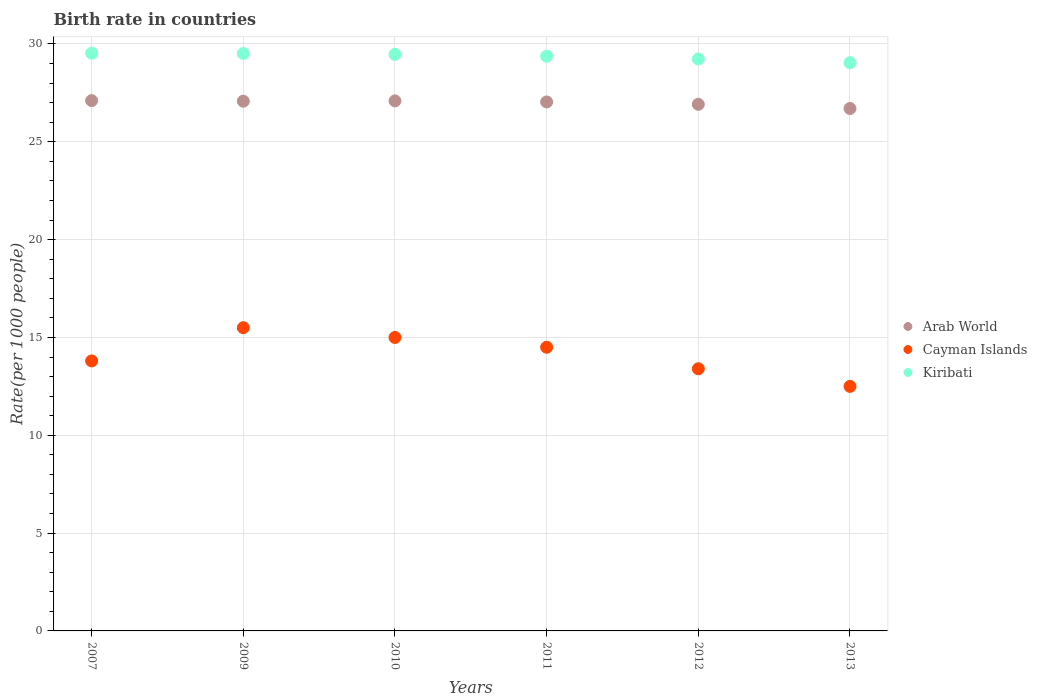How many different coloured dotlines are there?
Make the answer very short. 3. Is the number of dotlines equal to the number of legend labels?
Your answer should be compact. Yes. What is the birth rate in Cayman Islands in 2010?
Make the answer very short. 15. Across all years, what is the minimum birth rate in Kiribati?
Provide a short and direct response. 29.04. In which year was the birth rate in Cayman Islands maximum?
Give a very brief answer. 2009. In which year was the birth rate in Cayman Islands minimum?
Keep it short and to the point. 2013. What is the total birth rate in Cayman Islands in the graph?
Make the answer very short. 84.7. What is the difference between the birth rate in Cayman Islands in 2012 and that in 2013?
Keep it short and to the point. 0.9. What is the difference between the birth rate in Arab World in 2011 and the birth rate in Cayman Islands in 2010?
Your answer should be very brief. 12.04. What is the average birth rate in Arab World per year?
Your answer should be compact. 26.99. In the year 2011, what is the difference between the birth rate in Arab World and birth rate in Cayman Islands?
Offer a very short reply. 12.54. What is the ratio of the birth rate in Arab World in 2007 to that in 2013?
Keep it short and to the point. 1.02. Is the birth rate in Arab World in 2009 less than that in 2012?
Offer a terse response. No. Is the difference between the birth rate in Arab World in 2007 and 2012 greater than the difference between the birth rate in Cayman Islands in 2007 and 2012?
Provide a succinct answer. No. Is the sum of the birth rate in Kiribati in 2007 and 2011 greater than the maximum birth rate in Cayman Islands across all years?
Ensure brevity in your answer.  Yes. Is it the case that in every year, the sum of the birth rate in Kiribati and birth rate in Cayman Islands  is greater than the birth rate in Arab World?
Provide a succinct answer. Yes. Does the birth rate in Cayman Islands monotonically increase over the years?
Offer a very short reply. No. Is the birth rate in Cayman Islands strictly less than the birth rate in Arab World over the years?
Give a very brief answer. Yes. How many years are there in the graph?
Ensure brevity in your answer.  6. Are the values on the major ticks of Y-axis written in scientific E-notation?
Make the answer very short. No. Does the graph contain any zero values?
Offer a very short reply. No. What is the title of the graph?
Give a very brief answer. Birth rate in countries. Does "Pacific island small states" appear as one of the legend labels in the graph?
Provide a succinct answer. No. What is the label or title of the X-axis?
Offer a very short reply. Years. What is the label or title of the Y-axis?
Your answer should be compact. Rate(per 1000 people). What is the Rate(per 1000 people) of Arab World in 2007?
Ensure brevity in your answer.  27.11. What is the Rate(per 1000 people) of Cayman Islands in 2007?
Offer a very short reply. 13.8. What is the Rate(per 1000 people) in Kiribati in 2007?
Your response must be concise. 29.53. What is the Rate(per 1000 people) in Arab World in 2009?
Provide a succinct answer. 27.08. What is the Rate(per 1000 people) in Cayman Islands in 2009?
Ensure brevity in your answer.  15.5. What is the Rate(per 1000 people) in Kiribati in 2009?
Offer a very short reply. 29.51. What is the Rate(per 1000 people) in Arab World in 2010?
Make the answer very short. 27.09. What is the Rate(per 1000 people) in Kiribati in 2010?
Keep it short and to the point. 29.47. What is the Rate(per 1000 people) of Arab World in 2011?
Provide a short and direct response. 27.04. What is the Rate(per 1000 people) of Cayman Islands in 2011?
Provide a short and direct response. 14.5. What is the Rate(per 1000 people) of Kiribati in 2011?
Make the answer very short. 29.38. What is the Rate(per 1000 people) in Arab World in 2012?
Make the answer very short. 26.92. What is the Rate(per 1000 people) of Kiribati in 2012?
Give a very brief answer. 29.23. What is the Rate(per 1000 people) in Arab World in 2013?
Keep it short and to the point. 26.7. What is the Rate(per 1000 people) in Cayman Islands in 2013?
Your response must be concise. 12.5. What is the Rate(per 1000 people) of Kiribati in 2013?
Your answer should be very brief. 29.04. Across all years, what is the maximum Rate(per 1000 people) of Arab World?
Your answer should be compact. 27.11. Across all years, what is the maximum Rate(per 1000 people) of Cayman Islands?
Give a very brief answer. 15.5. Across all years, what is the maximum Rate(per 1000 people) of Kiribati?
Your response must be concise. 29.53. Across all years, what is the minimum Rate(per 1000 people) in Arab World?
Your answer should be compact. 26.7. Across all years, what is the minimum Rate(per 1000 people) of Kiribati?
Ensure brevity in your answer.  29.04. What is the total Rate(per 1000 people) in Arab World in the graph?
Your answer should be compact. 161.93. What is the total Rate(per 1000 people) of Cayman Islands in the graph?
Provide a short and direct response. 84.7. What is the total Rate(per 1000 people) of Kiribati in the graph?
Your answer should be compact. 176.16. What is the difference between the Rate(per 1000 people) of Arab World in 2007 and that in 2009?
Provide a short and direct response. 0.03. What is the difference between the Rate(per 1000 people) in Cayman Islands in 2007 and that in 2009?
Ensure brevity in your answer.  -1.7. What is the difference between the Rate(per 1000 people) of Kiribati in 2007 and that in 2009?
Ensure brevity in your answer.  0.01. What is the difference between the Rate(per 1000 people) of Arab World in 2007 and that in 2010?
Ensure brevity in your answer.  0.01. What is the difference between the Rate(per 1000 people) in Cayman Islands in 2007 and that in 2010?
Give a very brief answer. -1.2. What is the difference between the Rate(per 1000 people) of Arab World in 2007 and that in 2011?
Keep it short and to the point. 0.07. What is the difference between the Rate(per 1000 people) in Cayman Islands in 2007 and that in 2011?
Offer a very short reply. -0.7. What is the difference between the Rate(per 1000 people) in Kiribati in 2007 and that in 2011?
Offer a terse response. 0.15. What is the difference between the Rate(per 1000 people) of Arab World in 2007 and that in 2012?
Keep it short and to the point. 0.19. What is the difference between the Rate(per 1000 people) of Kiribati in 2007 and that in 2012?
Offer a terse response. 0.29. What is the difference between the Rate(per 1000 people) in Arab World in 2007 and that in 2013?
Provide a short and direct response. 0.4. What is the difference between the Rate(per 1000 people) of Kiribati in 2007 and that in 2013?
Provide a succinct answer. 0.48. What is the difference between the Rate(per 1000 people) of Arab World in 2009 and that in 2010?
Keep it short and to the point. -0.02. What is the difference between the Rate(per 1000 people) in Cayman Islands in 2009 and that in 2010?
Give a very brief answer. 0.5. What is the difference between the Rate(per 1000 people) of Kiribati in 2009 and that in 2010?
Keep it short and to the point. 0.04. What is the difference between the Rate(per 1000 people) in Arab World in 2009 and that in 2011?
Your answer should be compact. 0.04. What is the difference between the Rate(per 1000 people) in Kiribati in 2009 and that in 2011?
Your answer should be compact. 0.14. What is the difference between the Rate(per 1000 people) of Arab World in 2009 and that in 2012?
Make the answer very short. 0.16. What is the difference between the Rate(per 1000 people) in Kiribati in 2009 and that in 2012?
Your answer should be compact. 0.28. What is the difference between the Rate(per 1000 people) of Arab World in 2009 and that in 2013?
Ensure brevity in your answer.  0.37. What is the difference between the Rate(per 1000 people) in Kiribati in 2009 and that in 2013?
Your response must be concise. 0.47. What is the difference between the Rate(per 1000 people) in Arab World in 2010 and that in 2011?
Make the answer very short. 0.05. What is the difference between the Rate(per 1000 people) in Kiribati in 2010 and that in 2011?
Provide a succinct answer. 0.09. What is the difference between the Rate(per 1000 people) of Arab World in 2010 and that in 2012?
Ensure brevity in your answer.  0.17. What is the difference between the Rate(per 1000 people) of Cayman Islands in 2010 and that in 2012?
Provide a succinct answer. 1.6. What is the difference between the Rate(per 1000 people) of Kiribati in 2010 and that in 2012?
Give a very brief answer. 0.23. What is the difference between the Rate(per 1000 people) in Arab World in 2010 and that in 2013?
Your answer should be compact. 0.39. What is the difference between the Rate(per 1000 people) in Cayman Islands in 2010 and that in 2013?
Your answer should be compact. 2.5. What is the difference between the Rate(per 1000 people) in Kiribati in 2010 and that in 2013?
Keep it short and to the point. 0.42. What is the difference between the Rate(per 1000 people) of Arab World in 2011 and that in 2012?
Give a very brief answer. 0.12. What is the difference between the Rate(per 1000 people) in Cayman Islands in 2011 and that in 2012?
Give a very brief answer. 1.1. What is the difference between the Rate(per 1000 people) in Kiribati in 2011 and that in 2012?
Ensure brevity in your answer.  0.14. What is the difference between the Rate(per 1000 people) in Arab World in 2011 and that in 2013?
Your answer should be very brief. 0.33. What is the difference between the Rate(per 1000 people) of Kiribati in 2011 and that in 2013?
Give a very brief answer. 0.33. What is the difference between the Rate(per 1000 people) in Arab World in 2012 and that in 2013?
Your response must be concise. 0.21. What is the difference between the Rate(per 1000 people) of Kiribati in 2012 and that in 2013?
Provide a succinct answer. 0.19. What is the difference between the Rate(per 1000 people) in Arab World in 2007 and the Rate(per 1000 people) in Cayman Islands in 2009?
Offer a terse response. 11.61. What is the difference between the Rate(per 1000 people) of Arab World in 2007 and the Rate(per 1000 people) of Kiribati in 2009?
Your answer should be compact. -2.41. What is the difference between the Rate(per 1000 people) in Cayman Islands in 2007 and the Rate(per 1000 people) in Kiribati in 2009?
Your answer should be compact. -15.71. What is the difference between the Rate(per 1000 people) in Arab World in 2007 and the Rate(per 1000 people) in Cayman Islands in 2010?
Offer a very short reply. 12.11. What is the difference between the Rate(per 1000 people) in Arab World in 2007 and the Rate(per 1000 people) in Kiribati in 2010?
Provide a succinct answer. -2.36. What is the difference between the Rate(per 1000 people) of Cayman Islands in 2007 and the Rate(per 1000 people) of Kiribati in 2010?
Keep it short and to the point. -15.67. What is the difference between the Rate(per 1000 people) of Arab World in 2007 and the Rate(per 1000 people) of Cayman Islands in 2011?
Keep it short and to the point. 12.61. What is the difference between the Rate(per 1000 people) of Arab World in 2007 and the Rate(per 1000 people) of Kiribati in 2011?
Make the answer very short. -2.27. What is the difference between the Rate(per 1000 people) in Cayman Islands in 2007 and the Rate(per 1000 people) in Kiribati in 2011?
Give a very brief answer. -15.58. What is the difference between the Rate(per 1000 people) in Arab World in 2007 and the Rate(per 1000 people) in Cayman Islands in 2012?
Your answer should be very brief. 13.71. What is the difference between the Rate(per 1000 people) of Arab World in 2007 and the Rate(per 1000 people) of Kiribati in 2012?
Provide a short and direct response. -2.13. What is the difference between the Rate(per 1000 people) of Cayman Islands in 2007 and the Rate(per 1000 people) of Kiribati in 2012?
Give a very brief answer. -15.44. What is the difference between the Rate(per 1000 people) in Arab World in 2007 and the Rate(per 1000 people) in Cayman Islands in 2013?
Your answer should be compact. 14.61. What is the difference between the Rate(per 1000 people) of Arab World in 2007 and the Rate(per 1000 people) of Kiribati in 2013?
Offer a terse response. -1.94. What is the difference between the Rate(per 1000 people) of Cayman Islands in 2007 and the Rate(per 1000 people) of Kiribati in 2013?
Provide a short and direct response. -15.24. What is the difference between the Rate(per 1000 people) in Arab World in 2009 and the Rate(per 1000 people) in Cayman Islands in 2010?
Give a very brief answer. 12.08. What is the difference between the Rate(per 1000 people) of Arab World in 2009 and the Rate(per 1000 people) of Kiribati in 2010?
Make the answer very short. -2.39. What is the difference between the Rate(per 1000 people) of Cayman Islands in 2009 and the Rate(per 1000 people) of Kiribati in 2010?
Keep it short and to the point. -13.97. What is the difference between the Rate(per 1000 people) of Arab World in 2009 and the Rate(per 1000 people) of Cayman Islands in 2011?
Offer a very short reply. 12.58. What is the difference between the Rate(per 1000 people) of Arab World in 2009 and the Rate(per 1000 people) of Kiribati in 2011?
Your answer should be compact. -2.3. What is the difference between the Rate(per 1000 people) of Cayman Islands in 2009 and the Rate(per 1000 people) of Kiribati in 2011?
Your response must be concise. -13.88. What is the difference between the Rate(per 1000 people) in Arab World in 2009 and the Rate(per 1000 people) in Cayman Islands in 2012?
Offer a very short reply. 13.68. What is the difference between the Rate(per 1000 people) of Arab World in 2009 and the Rate(per 1000 people) of Kiribati in 2012?
Provide a succinct answer. -2.16. What is the difference between the Rate(per 1000 people) of Cayman Islands in 2009 and the Rate(per 1000 people) of Kiribati in 2012?
Make the answer very short. -13.73. What is the difference between the Rate(per 1000 people) of Arab World in 2009 and the Rate(per 1000 people) of Cayman Islands in 2013?
Your answer should be compact. 14.58. What is the difference between the Rate(per 1000 people) of Arab World in 2009 and the Rate(per 1000 people) of Kiribati in 2013?
Provide a succinct answer. -1.97. What is the difference between the Rate(per 1000 people) of Cayman Islands in 2009 and the Rate(per 1000 people) of Kiribati in 2013?
Provide a succinct answer. -13.54. What is the difference between the Rate(per 1000 people) in Arab World in 2010 and the Rate(per 1000 people) in Cayman Islands in 2011?
Your answer should be compact. 12.59. What is the difference between the Rate(per 1000 people) of Arab World in 2010 and the Rate(per 1000 people) of Kiribati in 2011?
Offer a very short reply. -2.28. What is the difference between the Rate(per 1000 people) in Cayman Islands in 2010 and the Rate(per 1000 people) in Kiribati in 2011?
Offer a terse response. -14.38. What is the difference between the Rate(per 1000 people) of Arab World in 2010 and the Rate(per 1000 people) of Cayman Islands in 2012?
Your answer should be compact. 13.69. What is the difference between the Rate(per 1000 people) in Arab World in 2010 and the Rate(per 1000 people) in Kiribati in 2012?
Offer a very short reply. -2.14. What is the difference between the Rate(per 1000 people) of Cayman Islands in 2010 and the Rate(per 1000 people) of Kiribati in 2012?
Ensure brevity in your answer.  -14.23. What is the difference between the Rate(per 1000 people) in Arab World in 2010 and the Rate(per 1000 people) in Cayman Islands in 2013?
Keep it short and to the point. 14.59. What is the difference between the Rate(per 1000 people) of Arab World in 2010 and the Rate(per 1000 people) of Kiribati in 2013?
Your response must be concise. -1.95. What is the difference between the Rate(per 1000 people) of Cayman Islands in 2010 and the Rate(per 1000 people) of Kiribati in 2013?
Keep it short and to the point. -14.04. What is the difference between the Rate(per 1000 people) of Arab World in 2011 and the Rate(per 1000 people) of Cayman Islands in 2012?
Keep it short and to the point. 13.64. What is the difference between the Rate(per 1000 people) of Arab World in 2011 and the Rate(per 1000 people) of Kiribati in 2012?
Ensure brevity in your answer.  -2.2. What is the difference between the Rate(per 1000 people) in Cayman Islands in 2011 and the Rate(per 1000 people) in Kiribati in 2012?
Provide a succinct answer. -14.73. What is the difference between the Rate(per 1000 people) in Arab World in 2011 and the Rate(per 1000 people) in Cayman Islands in 2013?
Keep it short and to the point. 14.54. What is the difference between the Rate(per 1000 people) in Arab World in 2011 and the Rate(per 1000 people) in Kiribati in 2013?
Give a very brief answer. -2.01. What is the difference between the Rate(per 1000 people) of Cayman Islands in 2011 and the Rate(per 1000 people) of Kiribati in 2013?
Give a very brief answer. -14.54. What is the difference between the Rate(per 1000 people) in Arab World in 2012 and the Rate(per 1000 people) in Cayman Islands in 2013?
Provide a short and direct response. 14.42. What is the difference between the Rate(per 1000 people) in Arab World in 2012 and the Rate(per 1000 people) in Kiribati in 2013?
Your response must be concise. -2.13. What is the difference between the Rate(per 1000 people) of Cayman Islands in 2012 and the Rate(per 1000 people) of Kiribati in 2013?
Give a very brief answer. -15.64. What is the average Rate(per 1000 people) in Arab World per year?
Offer a very short reply. 26.99. What is the average Rate(per 1000 people) of Cayman Islands per year?
Provide a short and direct response. 14.12. What is the average Rate(per 1000 people) of Kiribati per year?
Give a very brief answer. 29.36. In the year 2007, what is the difference between the Rate(per 1000 people) in Arab World and Rate(per 1000 people) in Cayman Islands?
Provide a succinct answer. 13.31. In the year 2007, what is the difference between the Rate(per 1000 people) in Arab World and Rate(per 1000 people) in Kiribati?
Offer a very short reply. -2.42. In the year 2007, what is the difference between the Rate(per 1000 people) of Cayman Islands and Rate(per 1000 people) of Kiribati?
Give a very brief answer. -15.73. In the year 2009, what is the difference between the Rate(per 1000 people) of Arab World and Rate(per 1000 people) of Cayman Islands?
Your answer should be compact. 11.58. In the year 2009, what is the difference between the Rate(per 1000 people) in Arab World and Rate(per 1000 people) in Kiribati?
Ensure brevity in your answer.  -2.44. In the year 2009, what is the difference between the Rate(per 1000 people) in Cayman Islands and Rate(per 1000 people) in Kiribati?
Offer a very short reply. -14.01. In the year 2010, what is the difference between the Rate(per 1000 people) of Arab World and Rate(per 1000 people) of Cayman Islands?
Your answer should be very brief. 12.09. In the year 2010, what is the difference between the Rate(per 1000 people) in Arab World and Rate(per 1000 people) in Kiribati?
Provide a short and direct response. -2.38. In the year 2010, what is the difference between the Rate(per 1000 people) of Cayman Islands and Rate(per 1000 people) of Kiribati?
Offer a terse response. -14.47. In the year 2011, what is the difference between the Rate(per 1000 people) of Arab World and Rate(per 1000 people) of Cayman Islands?
Give a very brief answer. 12.54. In the year 2011, what is the difference between the Rate(per 1000 people) of Arab World and Rate(per 1000 people) of Kiribati?
Give a very brief answer. -2.34. In the year 2011, what is the difference between the Rate(per 1000 people) of Cayman Islands and Rate(per 1000 people) of Kiribati?
Ensure brevity in your answer.  -14.88. In the year 2012, what is the difference between the Rate(per 1000 people) in Arab World and Rate(per 1000 people) in Cayman Islands?
Your answer should be compact. 13.52. In the year 2012, what is the difference between the Rate(per 1000 people) in Arab World and Rate(per 1000 people) in Kiribati?
Offer a very short reply. -2.32. In the year 2012, what is the difference between the Rate(per 1000 people) in Cayman Islands and Rate(per 1000 people) in Kiribati?
Provide a succinct answer. -15.84. In the year 2013, what is the difference between the Rate(per 1000 people) of Arab World and Rate(per 1000 people) of Cayman Islands?
Offer a very short reply. 14.2. In the year 2013, what is the difference between the Rate(per 1000 people) of Arab World and Rate(per 1000 people) of Kiribati?
Your answer should be compact. -2.34. In the year 2013, what is the difference between the Rate(per 1000 people) of Cayman Islands and Rate(per 1000 people) of Kiribati?
Make the answer very short. -16.54. What is the ratio of the Rate(per 1000 people) of Cayman Islands in 2007 to that in 2009?
Ensure brevity in your answer.  0.89. What is the ratio of the Rate(per 1000 people) of Kiribati in 2007 to that in 2009?
Provide a short and direct response. 1. What is the ratio of the Rate(per 1000 people) in Cayman Islands in 2007 to that in 2010?
Give a very brief answer. 0.92. What is the ratio of the Rate(per 1000 people) in Cayman Islands in 2007 to that in 2011?
Offer a terse response. 0.95. What is the ratio of the Rate(per 1000 people) of Cayman Islands in 2007 to that in 2012?
Offer a terse response. 1.03. What is the ratio of the Rate(per 1000 people) of Kiribati in 2007 to that in 2012?
Provide a short and direct response. 1.01. What is the ratio of the Rate(per 1000 people) in Arab World in 2007 to that in 2013?
Your answer should be very brief. 1.01. What is the ratio of the Rate(per 1000 people) in Cayman Islands in 2007 to that in 2013?
Ensure brevity in your answer.  1.1. What is the ratio of the Rate(per 1000 people) of Kiribati in 2007 to that in 2013?
Provide a short and direct response. 1.02. What is the ratio of the Rate(per 1000 people) in Arab World in 2009 to that in 2010?
Your answer should be very brief. 1. What is the ratio of the Rate(per 1000 people) in Cayman Islands in 2009 to that in 2010?
Ensure brevity in your answer.  1.03. What is the ratio of the Rate(per 1000 people) in Arab World in 2009 to that in 2011?
Keep it short and to the point. 1. What is the ratio of the Rate(per 1000 people) in Cayman Islands in 2009 to that in 2011?
Give a very brief answer. 1.07. What is the ratio of the Rate(per 1000 people) of Kiribati in 2009 to that in 2011?
Provide a succinct answer. 1. What is the ratio of the Rate(per 1000 people) in Arab World in 2009 to that in 2012?
Your response must be concise. 1.01. What is the ratio of the Rate(per 1000 people) in Cayman Islands in 2009 to that in 2012?
Keep it short and to the point. 1.16. What is the ratio of the Rate(per 1000 people) in Kiribati in 2009 to that in 2012?
Ensure brevity in your answer.  1.01. What is the ratio of the Rate(per 1000 people) of Arab World in 2009 to that in 2013?
Your answer should be compact. 1.01. What is the ratio of the Rate(per 1000 people) of Cayman Islands in 2009 to that in 2013?
Offer a terse response. 1.24. What is the ratio of the Rate(per 1000 people) in Kiribati in 2009 to that in 2013?
Offer a terse response. 1.02. What is the ratio of the Rate(per 1000 people) of Arab World in 2010 to that in 2011?
Provide a short and direct response. 1. What is the ratio of the Rate(per 1000 people) in Cayman Islands in 2010 to that in 2011?
Your answer should be compact. 1.03. What is the ratio of the Rate(per 1000 people) of Arab World in 2010 to that in 2012?
Ensure brevity in your answer.  1.01. What is the ratio of the Rate(per 1000 people) in Cayman Islands in 2010 to that in 2012?
Your response must be concise. 1.12. What is the ratio of the Rate(per 1000 people) in Arab World in 2010 to that in 2013?
Keep it short and to the point. 1.01. What is the ratio of the Rate(per 1000 people) in Kiribati in 2010 to that in 2013?
Your response must be concise. 1.01. What is the ratio of the Rate(per 1000 people) of Arab World in 2011 to that in 2012?
Your answer should be compact. 1. What is the ratio of the Rate(per 1000 people) in Cayman Islands in 2011 to that in 2012?
Give a very brief answer. 1.08. What is the ratio of the Rate(per 1000 people) in Kiribati in 2011 to that in 2012?
Your response must be concise. 1. What is the ratio of the Rate(per 1000 people) of Arab World in 2011 to that in 2013?
Give a very brief answer. 1.01. What is the ratio of the Rate(per 1000 people) of Cayman Islands in 2011 to that in 2013?
Your answer should be very brief. 1.16. What is the ratio of the Rate(per 1000 people) in Kiribati in 2011 to that in 2013?
Your answer should be compact. 1.01. What is the ratio of the Rate(per 1000 people) in Cayman Islands in 2012 to that in 2013?
Your answer should be very brief. 1.07. What is the ratio of the Rate(per 1000 people) of Kiribati in 2012 to that in 2013?
Keep it short and to the point. 1.01. What is the difference between the highest and the second highest Rate(per 1000 people) of Arab World?
Your response must be concise. 0.01. What is the difference between the highest and the second highest Rate(per 1000 people) in Cayman Islands?
Make the answer very short. 0.5. What is the difference between the highest and the second highest Rate(per 1000 people) of Kiribati?
Provide a succinct answer. 0.01. What is the difference between the highest and the lowest Rate(per 1000 people) of Arab World?
Your response must be concise. 0.4. What is the difference between the highest and the lowest Rate(per 1000 people) in Cayman Islands?
Provide a succinct answer. 3. What is the difference between the highest and the lowest Rate(per 1000 people) in Kiribati?
Your answer should be very brief. 0.48. 